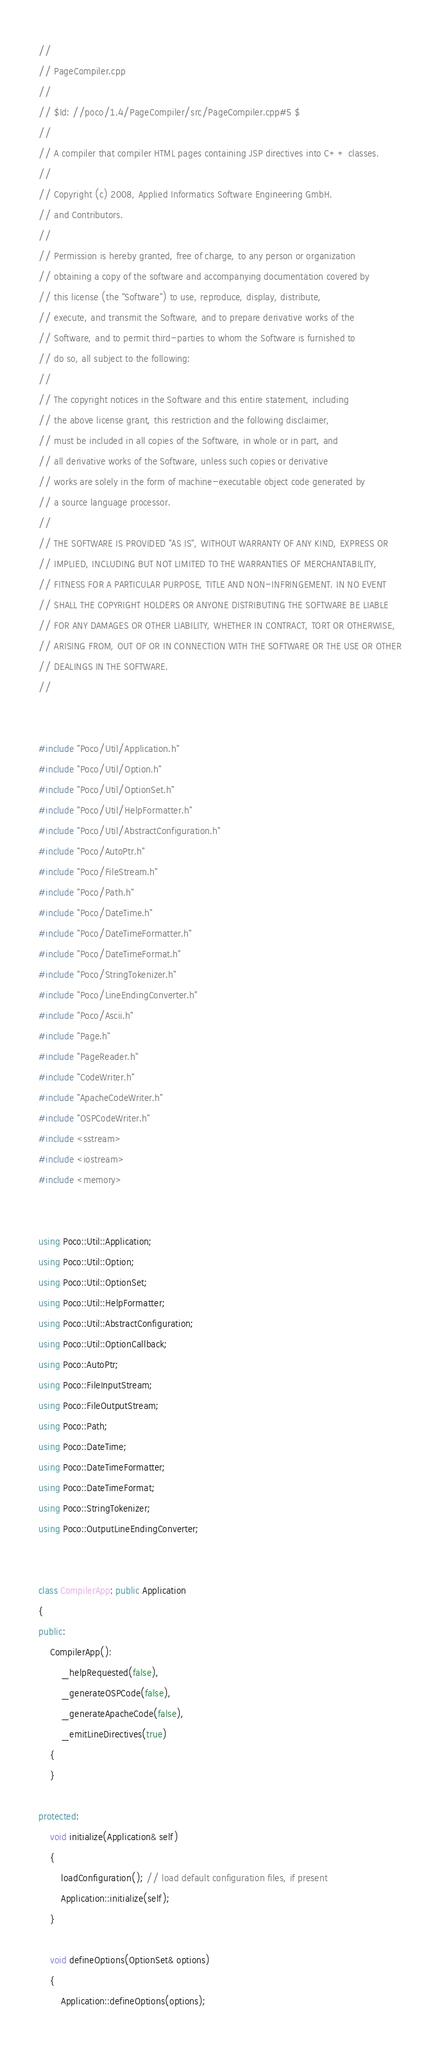<code> <loc_0><loc_0><loc_500><loc_500><_C++_>//
// PageCompiler.cpp
//
// $Id: //poco/1.4/PageCompiler/src/PageCompiler.cpp#5 $
//
// A compiler that compiler HTML pages containing JSP directives into C++ classes.
//
// Copyright (c) 2008, Applied Informatics Software Engineering GmbH.
// and Contributors.
//
// Permission is hereby granted, free of charge, to any person or organization
// obtaining a copy of the software and accompanying documentation covered by
// this license (the "Software") to use, reproduce, display, distribute,
// execute, and transmit the Software, and to prepare derivative works of the
// Software, and to permit third-parties to whom the Software is furnished to
// do so, all subject to the following:
// 
// The copyright notices in the Software and this entire statement, including
// the above license grant, this restriction and the following disclaimer,
// must be included in all copies of the Software, in whole or in part, and
// all derivative works of the Software, unless such copies or derivative
// works are solely in the form of machine-executable object code generated by
// a source language processor.
// 
// THE SOFTWARE IS PROVIDED "AS IS", WITHOUT WARRANTY OF ANY KIND, EXPRESS OR
// IMPLIED, INCLUDING BUT NOT LIMITED TO THE WARRANTIES OF MERCHANTABILITY,
// FITNESS FOR A PARTICULAR PURPOSE, TITLE AND NON-INFRINGEMENT. IN NO EVENT
// SHALL THE COPYRIGHT HOLDERS OR ANYONE DISTRIBUTING THE SOFTWARE BE LIABLE
// FOR ANY DAMAGES OR OTHER LIABILITY, WHETHER IN CONTRACT, TORT OR OTHERWISE,
// ARISING FROM, OUT OF OR IN CONNECTION WITH THE SOFTWARE OR THE USE OR OTHER
// DEALINGS IN THE SOFTWARE.
//


#include "Poco/Util/Application.h"
#include "Poco/Util/Option.h"
#include "Poco/Util/OptionSet.h"
#include "Poco/Util/HelpFormatter.h"
#include "Poco/Util/AbstractConfiguration.h"
#include "Poco/AutoPtr.h"
#include "Poco/FileStream.h"
#include "Poco/Path.h"
#include "Poco/DateTime.h"
#include "Poco/DateTimeFormatter.h"
#include "Poco/DateTimeFormat.h"
#include "Poco/StringTokenizer.h"
#include "Poco/LineEndingConverter.h"
#include "Poco/Ascii.h"
#include "Page.h"
#include "PageReader.h"
#include "CodeWriter.h"
#include "ApacheCodeWriter.h"
#include "OSPCodeWriter.h"
#include <sstream>
#include <iostream>
#include <memory>


using Poco::Util::Application;
using Poco::Util::Option;
using Poco::Util::OptionSet;
using Poco::Util::HelpFormatter;
using Poco::Util::AbstractConfiguration;
using Poco::Util::OptionCallback;
using Poco::AutoPtr;
using Poco::FileInputStream;
using Poco::FileOutputStream;
using Poco::Path;
using Poco::DateTime;
using Poco::DateTimeFormatter;
using Poco::DateTimeFormat;
using Poco::StringTokenizer;
using Poco::OutputLineEndingConverter;


class CompilerApp: public Application
{
public:
	CompilerApp(): 
		_helpRequested(false),
		_generateOSPCode(false),
		_generateApacheCode(false),
		_emitLineDirectives(true)
	{
	}

protected:	
	void initialize(Application& self)
	{
		loadConfiguration(); // load default configuration files, if present
		Application::initialize(self);
	}
	
	void defineOptions(OptionSet& options)
	{
		Application::defineOptions(options);
</code> 